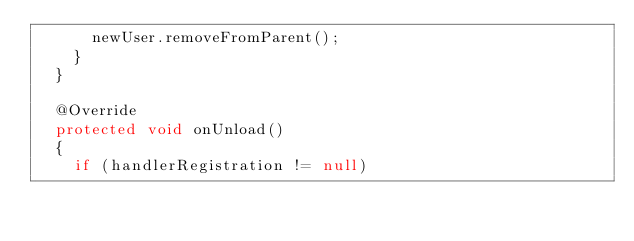<code> <loc_0><loc_0><loc_500><loc_500><_Java_>			newUser.removeFromParent();
		}
	}

	@Override
	protected void onUnload()
	{
		if (handlerRegistration != null)</code> 